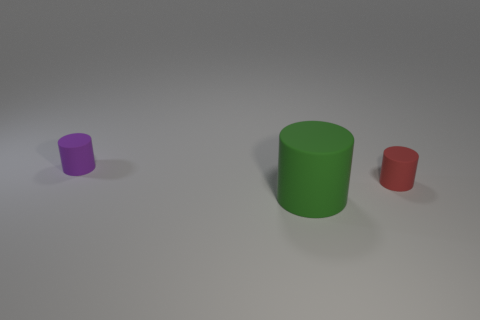Subtract all purple rubber cylinders. How many cylinders are left? 2 Add 3 blue rubber things. How many objects exist? 6 Subtract all green balls. How many brown cylinders are left? 0 Subtract all green cylinders. How many cylinders are left? 2 Subtract 3 cylinders. How many cylinders are left? 0 Add 1 tiny matte things. How many tiny matte things are left? 3 Add 3 small cyan cubes. How many small cyan cubes exist? 3 Subtract 1 green cylinders. How many objects are left? 2 Subtract all cyan cylinders. Subtract all green blocks. How many cylinders are left? 3 Subtract all red objects. Subtract all purple shiny blocks. How many objects are left? 2 